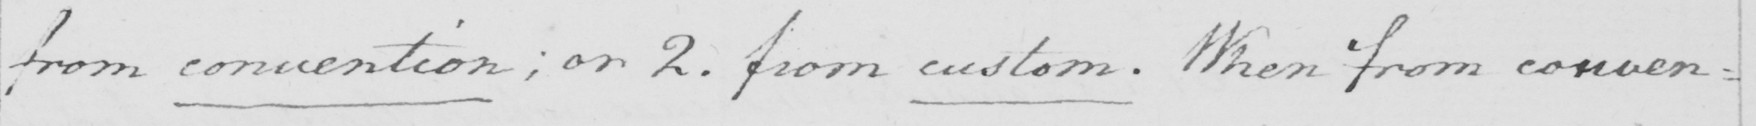What text is written in this handwritten line? from convention ; or 2 . from custom . When from conven= 